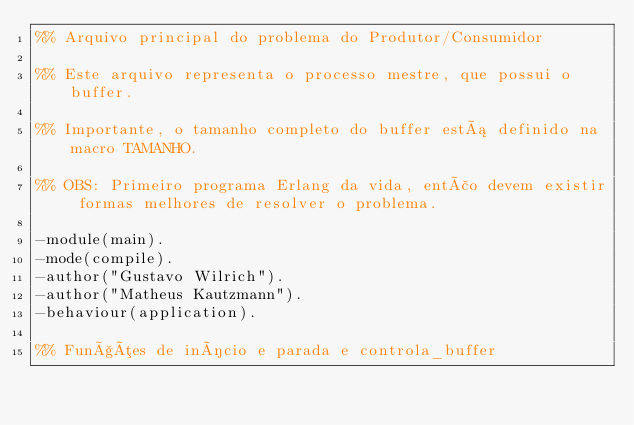Convert code to text. <code><loc_0><loc_0><loc_500><loc_500><_Erlang_>%% Arquivo principal do problema do Produtor/Consumidor

%% Este arquivo representa o processo mestre, que possui o buffer.

%% Importante, o tamanho completo do buffer está definido na macro TAMANHO.

%% OBS: Primeiro programa Erlang da vida, então devem existir formas melhores de resolver o problema.

-module(main).
-mode(compile).
-author("Gustavo Wilrich").
-author("Matheus Kautzmann").
-behaviour(application).

%% Funções de início e parada e controla_buffer</code> 